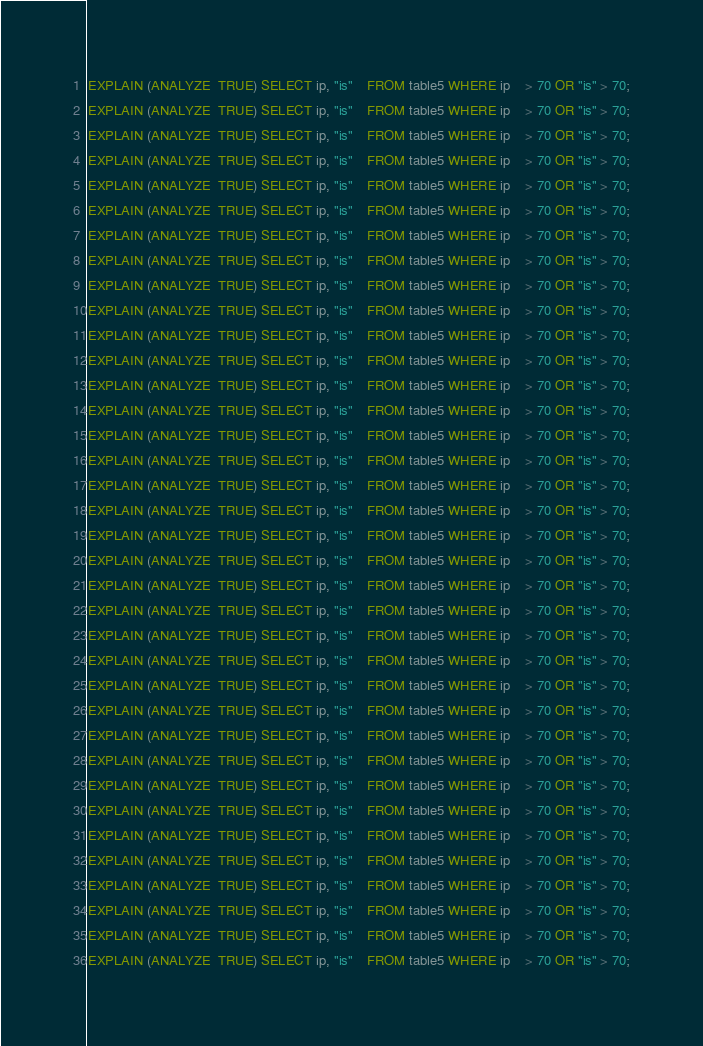Convert code to text. <code><loc_0><loc_0><loc_500><loc_500><_SQL_>EXPLAIN (ANALYZE  TRUE) SELECT ip, "is"	FROM table5 WHERE ip 	> 70 OR "is" > 70;
EXPLAIN (ANALYZE  TRUE) SELECT ip, "is"	FROM table5 WHERE ip 	> 70 OR "is" > 70;
EXPLAIN (ANALYZE  TRUE) SELECT ip, "is"	FROM table5 WHERE ip 	> 70 OR "is" > 70;
EXPLAIN (ANALYZE  TRUE) SELECT ip, "is"	FROM table5 WHERE ip 	> 70 OR "is" > 70;
EXPLAIN (ANALYZE  TRUE) SELECT ip, "is"	FROM table5 WHERE ip 	> 70 OR "is" > 70;
EXPLAIN (ANALYZE  TRUE) SELECT ip, "is"	FROM table5 WHERE ip 	> 70 OR "is" > 70;
EXPLAIN (ANALYZE  TRUE) SELECT ip, "is"	FROM table5 WHERE ip 	> 70 OR "is" > 70;
EXPLAIN (ANALYZE  TRUE) SELECT ip, "is"	FROM table5 WHERE ip 	> 70 OR "is" > 70;
EXPLAIN (ANALYZE  TRUE) SELECT ip, "is"	FROM table5 WHERE ip 	> 70 OR "is" > 70;
EXPLAIN (ANALYZE  TRUE) SELECT ip, "is"	FROM table5 WHERE ip 	> 70 OR "is" > 70;
EXPLAIN (ANALYZE  TRUE) SELECT ip, "is"	FROM table5 WHERE ip 	> 70 OR "is" > 70;
EXPLAIN (ANALYZE  TRUE) SELECT ip, "is"	FROM table5 WHERE ip 	> 70 OR "is" > 70;
EXPLAIN (ANALYZE  TRUE) SELECT ip, "is"	FROM table5 WHERE ip 	> 70 OR "is" > 70;
EXPLAIN (ANALYZE  TRUE) SELECT ip, "is"	FROM table5 WHERE ip 	> 70 OR "is" > 70;
EXPLAIN (ANALYZE  TRUE) SELECT ip, "is"	FROM table5 WHERE ip 	> 70 OR "is" > 70;
EXPLAIN (ANALYZE  TRUE) SELECT ip, "is"	FROM table5 WHERE ip 	> 70 OR "is" > 70;
EXPLAIN (ANALYZE  TRUE) SELECT ip, "is"	FROM table5 WHERE ip 	> 70 OR "is" > 70;
EXPLAIN (ANALYZE  TRUE) SELECT ip, "is"	FROM table5 WHERE ip 	> 70 OR "is" > 70;
EXPLAIN (ANALYZE  TRUE) SELECT ip, "is"	FROM table5 WHERE ip 	> 70 OR "is" > 70;
EXPLAIN (ANALYZE  TRUE) SELECT ip, "is"	FROM table5 WHERE ip 	> 70 OR "is" > 70;
EXPLAIN (ANALYZE  TRUE) SELECT ip, "is"	FROM table5 WHERE ip 	> 70 OR "is" > 70;
EXPLAIN (ANALYZE  TRUE) SELECT ip, "is"	FROM table5 WHERE ip 	> 70 OR "is" > 70;
EXPLAIN (ANALYZE  TRUE) SELECT ip, "is"	FROM table5 WHERE ip 	> 70 OR "is" > 70;
EXPLAIN (ANALYZE  TRUE) SELECT ip, "is"	FROM table5 WHERE ip 	> 70 OR "is" > 70;
EXPLAIN (ANALYZE  TRUE) SELECT ip, "is"	FROM table5 WHERE ip 	> 70 OR "is" > 70;
EXPLAIN (ANALYZE  TRUE) SELECT ip, "is"	FROM table5 WHERE ip 	> 70 OR "is" > 70;
EXPLAIN (ANALYZE  TRUE) SELECT ip, "is"	FROM table5 WHERE ip 	> 70 OR "is" > 70;
EXPLAIN (ANALYZE  TRUE) SELECT ip, "is"	FROM table5 WHERE ip 	> 70 OR "is" > 70;
EXPLAIN (ANALYZE  TRUE) SELECT ip, "is"	FROM table5 WHERE ip 	> 70 OR "is" > 70;
EXPLAIN (ANALYZE  TRUE) SELECT ip, "is"	FROM table5 WHERE ip 	> 70 OR "is" > 70;
EXPLAIN (ANALYZE  TRUE) SELECT ip, "is"	FROM table5 WHERE ip 	> 70 OR "is" > 70;
EXPLAIN (ANALYZE  TRUE) SELECT ip, "is"	FROM table5 WHERE ip 	> 70 OR "is" > 70;
EXPLAIN (ANALYZE  TRUE) SELECT ip, "is"	FROM table5 WHERE ip 	> 70 OR "is" > 70;
EXPLAIN (ANALYZE  TRUE) SELECT ip, "is"	FROM table5 WHERE ip 	> 70 OR "is" > 70;
EXPLAIN (ANALYZE  TRUE) SELECT ip, "is"	FROM table5 WHERE ip 	> 70 OR "is" > 70;
EXPLAIN (ANALYZE  TRUE) SELECT ip, "is"	FROM table5 WHERE ip 	> 70 OR "is" > 70;</code> 